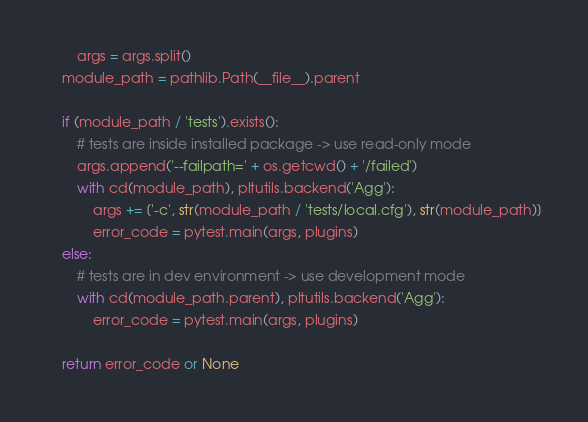<code> <loc_0><loc_0><loc_500><loc_500><_Python_>        args = args.split()
    module_path = pathlib.Path(__file__).parent

    if (module_path / 'tests').exists():
        # tests are inside installed package -> use read-only mode
        args.append('--failpath=' + os.getcwd() + '/failed')
        with cd(module_path), pltutils.backend('Agg'):
            args += ['-c', str(module_path / 'tests/local.cfg'), str(module_path)]
            error_code = pytest.main(args, plugins)
    else:
        # tests are in dev environment -> use development mode
        with cd(module_path.parent), pltutils.backend('Agg'):
            error_code = pytest.main(args, plugins)

    return error_code or None
</code> 